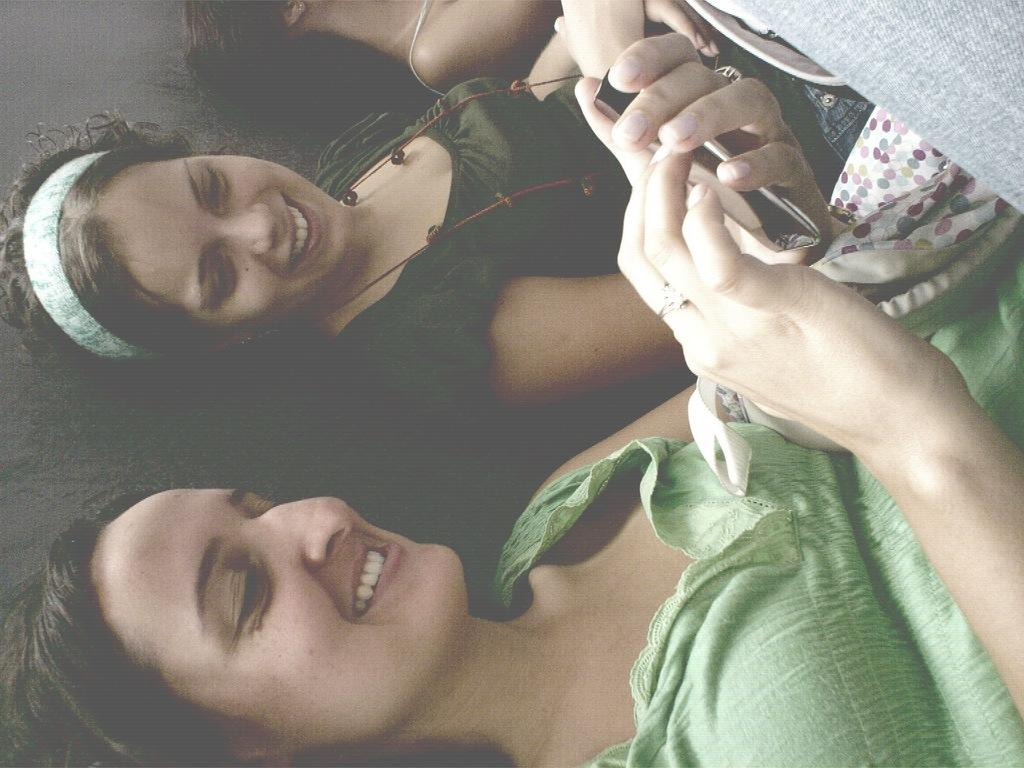How many people are in the image? There are two women in the image. What are the women doing in the image? The women are sitting and watching a mobile. What type of ice does the grandfather in the image enjoy? There is no grandfather or ice mentioned in the image; it features two women sitting and watching a mobile. 